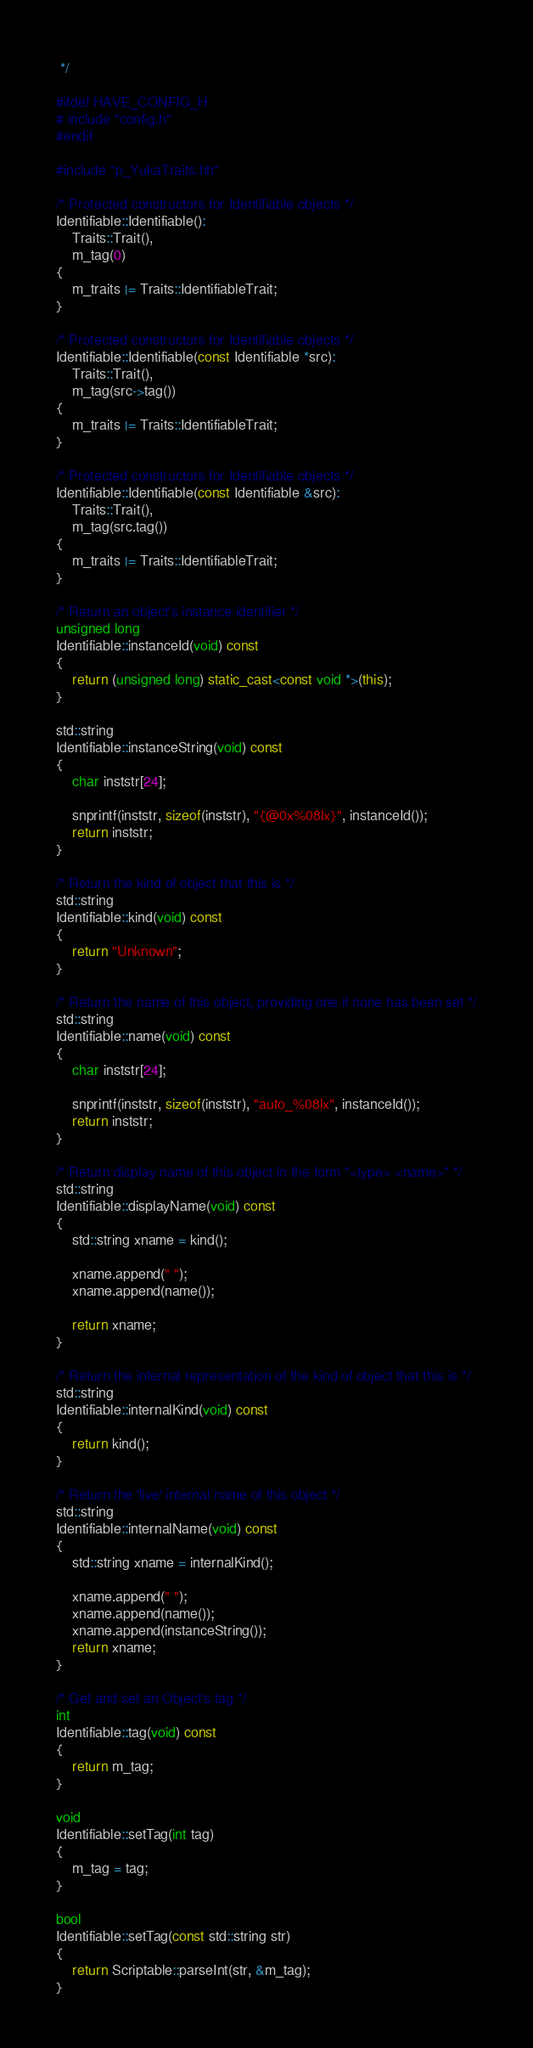<code> <loc_0><loc_0><loc_500><loc_500><_C++_> */

#ifdef HAVE_CONFIG_H
# include "config.h"
#endif

#include "p_YukaTraits.hh"

/* Protected constructors for Identifiable objects */
Identifiable::Identifiable():
	Traits::Trait(),
	m_tag(0)
{
	m_traits |= Traits::IdentifiableTrait;
}

/* Protected constructors for Identifiable objects */
Identifiable::Identifiable(const Identifiable *src):
	Traits::Trait(),
	m_tag(src->tag())
{
	m_traits |= Traits::IdentifiableTrait;
}

/* Protected constructors for Identifiable objects */
Identifiable::Identifiable(const Identifiable &src):
	Traits::Trait(),
	m_tag(src.tag())
{
	m_traits |= Traits::IdentifiableTrait;
}

/* Return an object's instance identifier */
unsigned long
Identifiable::instanceId(void) const
{
	return (unsigned long) static_cast<const void *>(this);
}

std::string
Identifiable::instanceString(void) const
{
	char inststr[24];
	
	snprintf(inststr, sizeof(inststr), "{@0x%08lx}", instanceId());
	return inststr;
}

/* Return the kind of object that this is */
std::string
Identifiable::kind(void) const
{
	return "Unknown";
}

/* Return the name of this object, providing one if none has been set */
std::string
Identifiable::name(void) const
{
	char inststr[24];
	
	snprintf(inststr, sizeof(inststr), "auto_%08lx", instanceId());
	return inststr;
}

/* Return display name of this object in the form "<type> <name>" */
std::string
Identifiable::displayName(void) const
{
	std::string xname = kind();
	
	xname.append(" ");
	xname.append(name());

	return xname;
}

/* Return the internal representation of the kind of object that this is */
std::string
Identifiable::internalKind(void) const
{
	return kind();
}

/* Return the 'live' internal name of this object */
std::string
Identifiable::internalName(void) const
{
	std::string xname = internalKind();

	xname.append(" ");
	xname.append(name());
	xname.append(instanceString());
	return xname;
}

/* Get and set an Object's tag */
int
Identifiable::tag(void) const
{
	return m_tag;
}

void
Identifiable::setTag(int tag)
{
	m_tag = tag;
}

bool
Identifiable::setTag(const std::string str)
{
	return Scriptable::parseInt(str, &m_tag);
}
</code> 